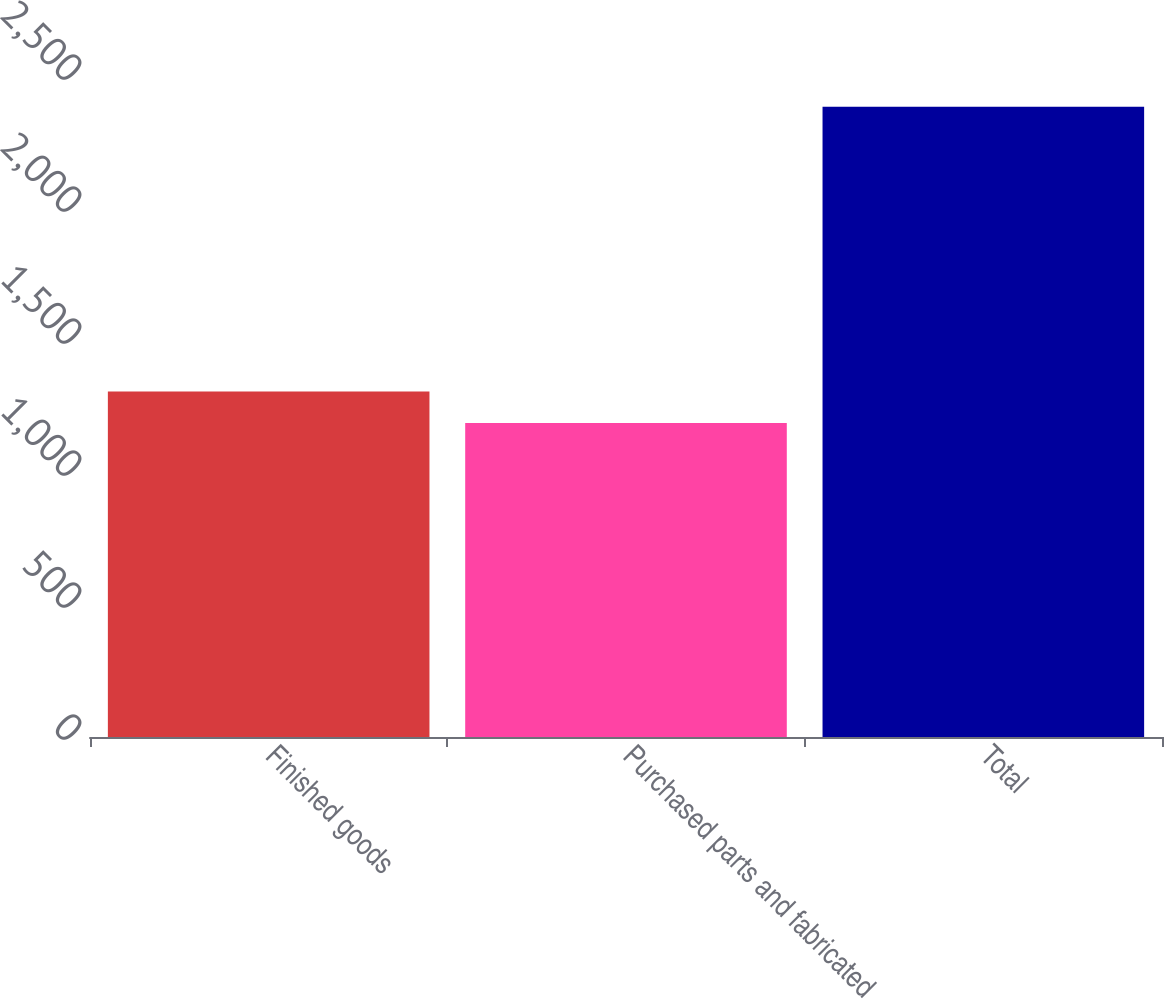<chart> <loc_0><loc_0><loc_500><loc_500><bar_chart><fcel>Finished goods<fcel>Purchased parts and fabricated<fcel>Total<nl><fcel>1308.8<fcel>1189<fcel>2387<nl></chart> 